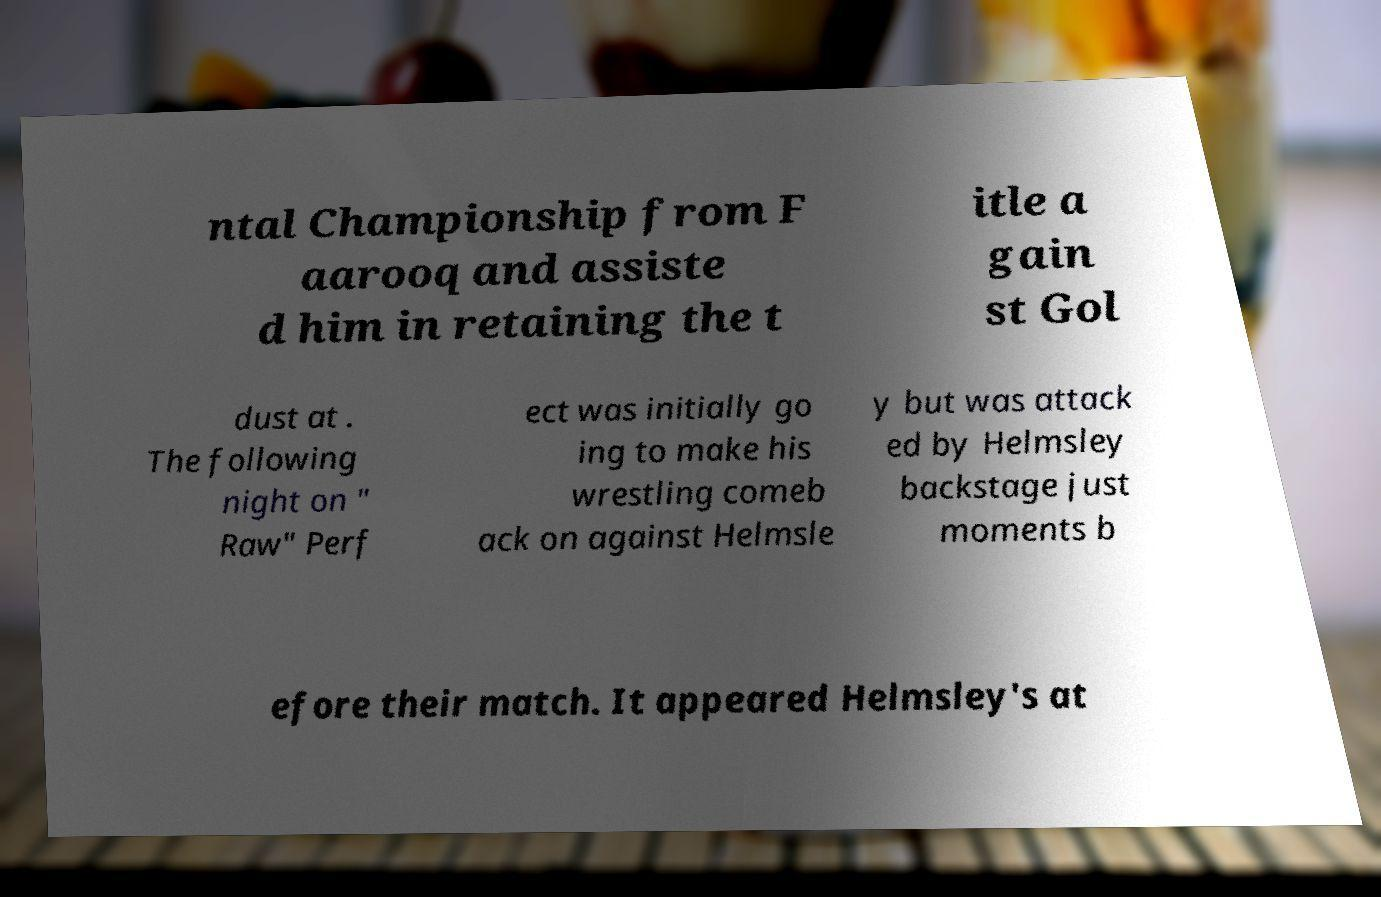I need the written content from this picture converted into text. Can you do that? ntal Championship from F aarooq and assiste d him in retaining the t itle a gain st Gol dust at . The following night on " Raw" Perf ect was initially go ing to make his wrestling comeb ack on against Helmsle y but was attack ed by Helmsley backstage just moments b efore their match. It appeared Helmsley's at 